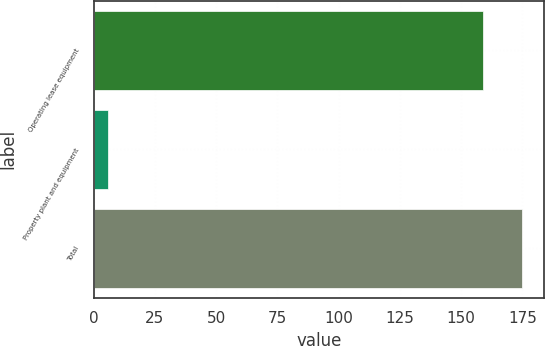<chart> <loc_0><loc_0><loc_500><loc_500><bar_chart><fcel>Operating lease equipment<fcel>Property plant and equipment<fcel>Total<nl><fcel>159<fcel>6<fcel>174.9<nl></chart> 